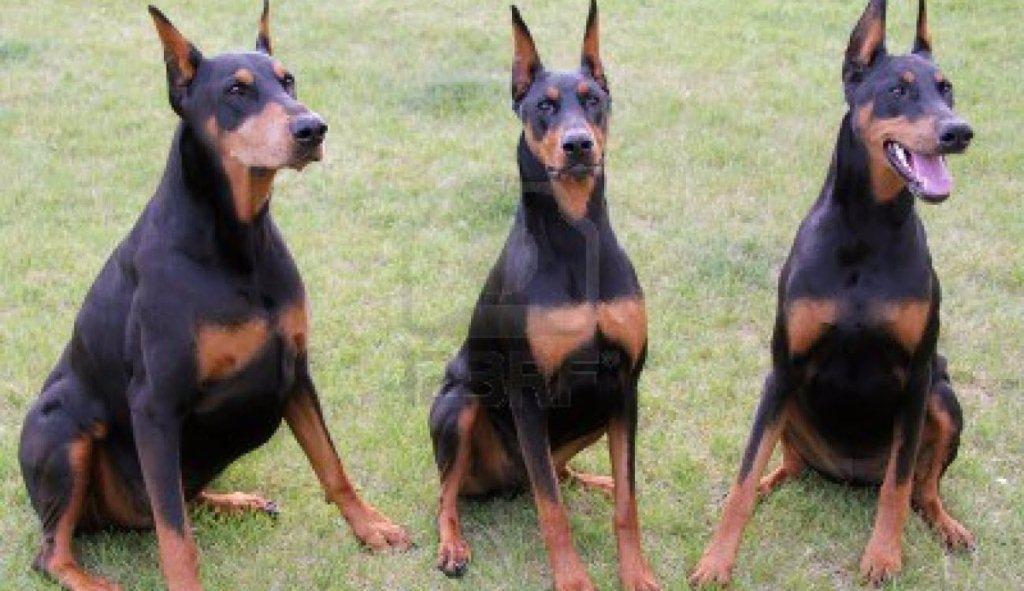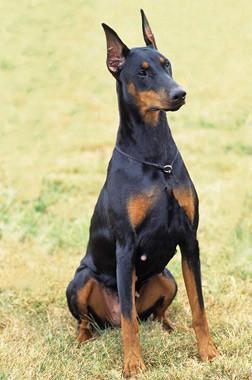The first image is the image on the left, the second image is the image on the right. For the images shown, is this caption "Three dogs are sitting in the grass in one of the images." true? Answer yes or no. Yes. The first image is the image on the left, the second image is the image on the right. For the images shown, is this caption "There are four dogs." true? Answer yes or no. Yes. 